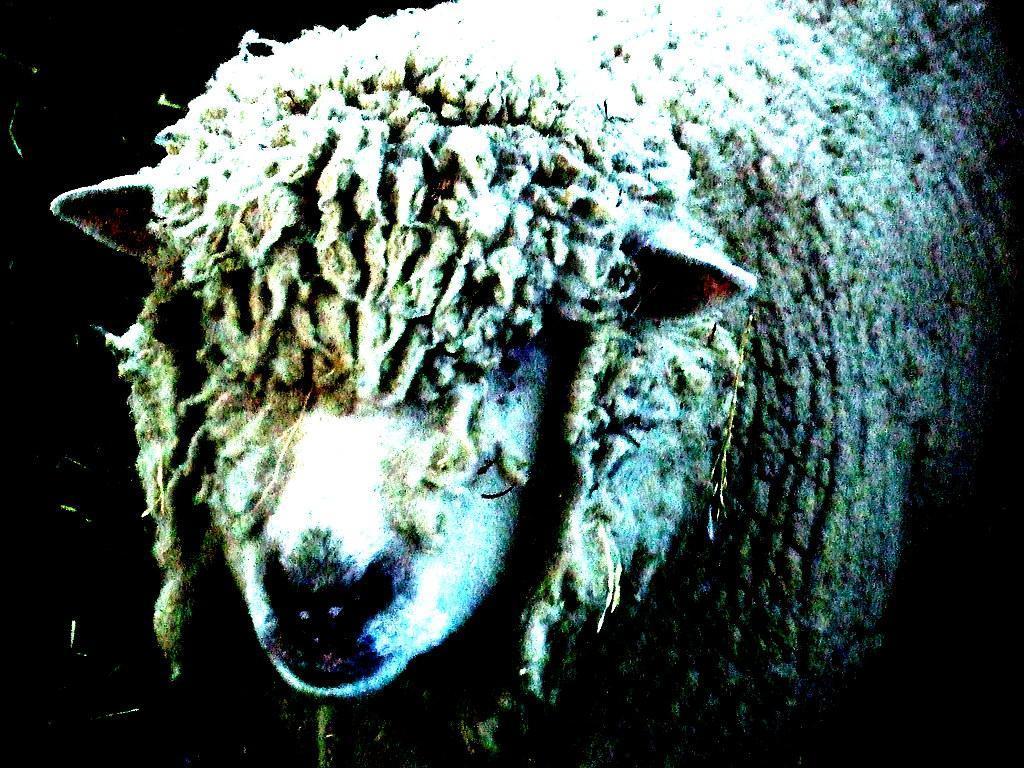Describe this image in one or two sentences. In the center of the image we can see an animal. And we can see the dark background. 